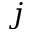<formula> <loc_0><loc_0><loc_500><loc_500>j</formula> 